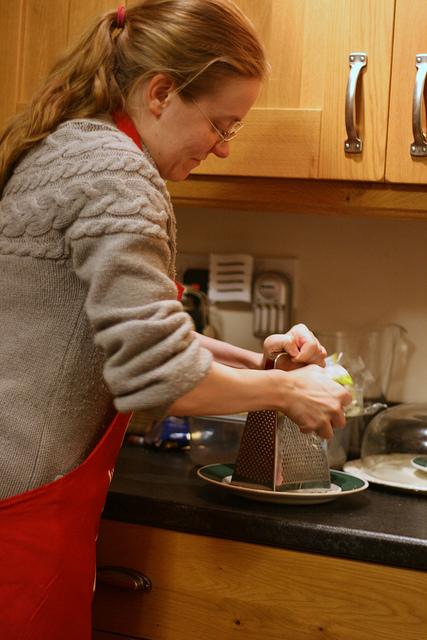What is the person doing?
Be succinct. Grating. What color is the apron?
Keep it brief. Red. How is the ladies hair fixed?
Be succinct. Ponytail. 